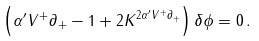<formula> <loc_0><loc_0><loc_500><loc_500>\left ( \alpha ^ { \prime } V ^ { + } \partial _ { + } - 1 + 2 K ^ { 2 \alpha ^ { \prime } V ^ { + } \partial _ { + } } \right ) \delta \phi = 0 \, .</formula> 